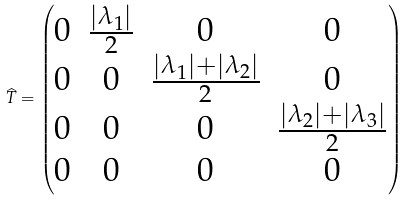<formula> <loc_0><loc_0><loc_500><loc_500>\widehat { T } = \begin{pmatrix} 0 & \frac { | \lambda _ { 1 } | } { 2 } & 0 & 0 \\ 0 & 0 & \frac { | \lambda _ { 1 } | + | \lambda _ { 2 } | } { 2 } & 0 \\ 0 & 0 & 0 & \frac { | \lambda _ { 2 } | + | \lambda _ { 3 } | } { 2 } \\ 0 & 0 & 0 & 0 \end{pmatrix}</formula> 